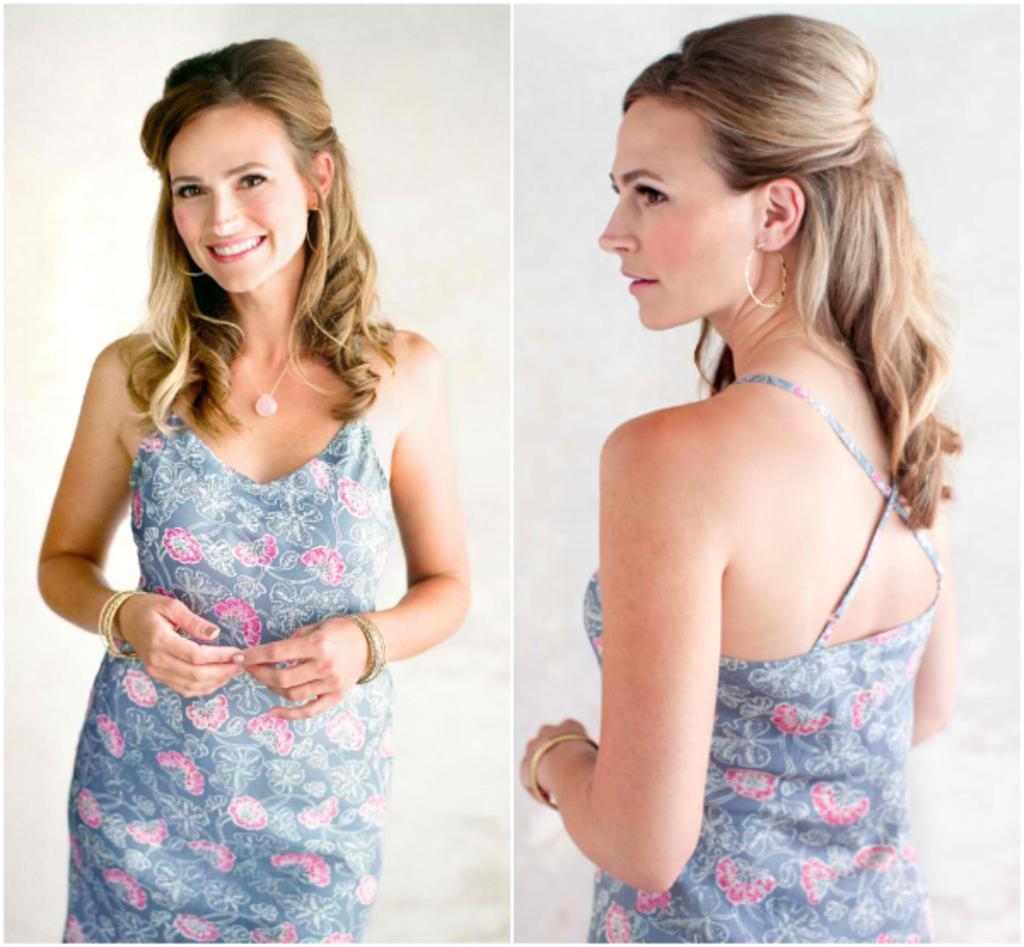Please provide a concise description of this image. This is an edited collage image , where there is a person standing and smiling , and on the other side of the image , there is same person standing in different angle , and there is white background. 